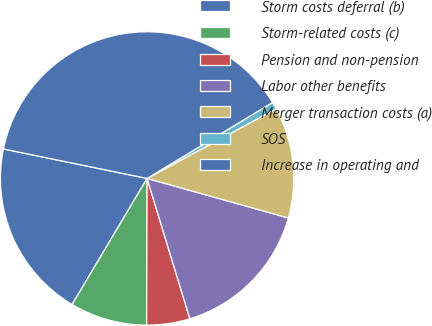<chart> <loc_0><loc_0><loc_500><loc_500><pie_chart><fcel>Storm costs deferral (b)<fcel>Storm-related costs (c)<fcel>Pension and non-pension<fcel>Labor other benefits<fcel>Merger transaction costs (a)<fcel>SOS<fcel>Increase in operating and<nl><fcel>19.68%<fcel>8.49%<fcel>4.76%<fcel>15.95%<fcel>12.22%<fcel>0.79%<fcel>38.1%<nl></chart> 